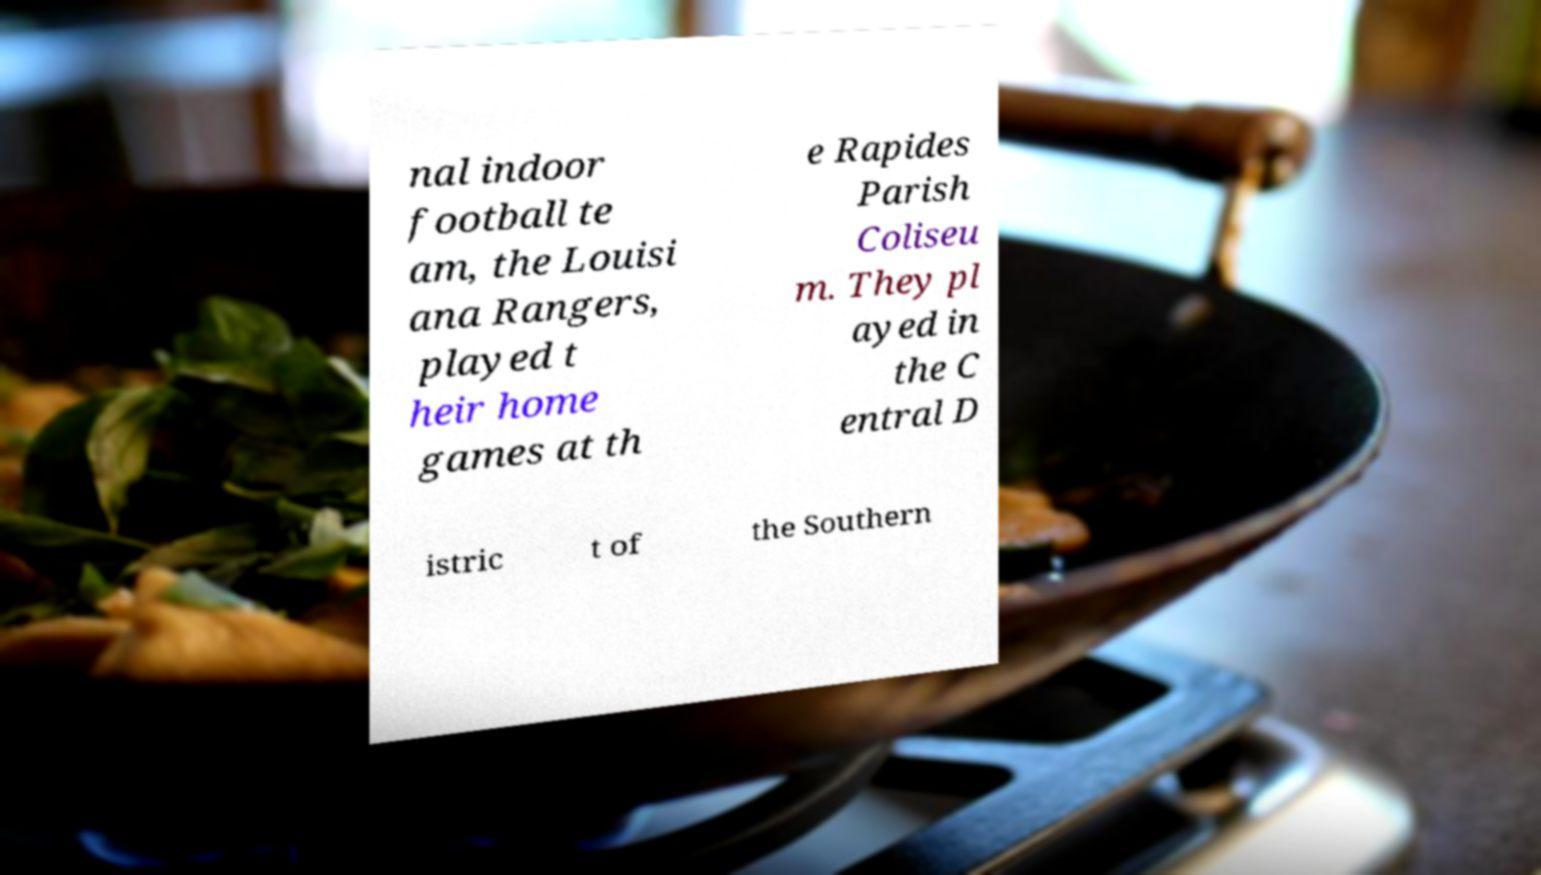For documentation purposes, I need the text within this image transcribed. Could you provide that? nal indoor football te am, the Louisi ana Rangers, played t heir home games at th e Rapides Parish Coliseu m. They pl ayed in the C entral D istric t of the Southern 